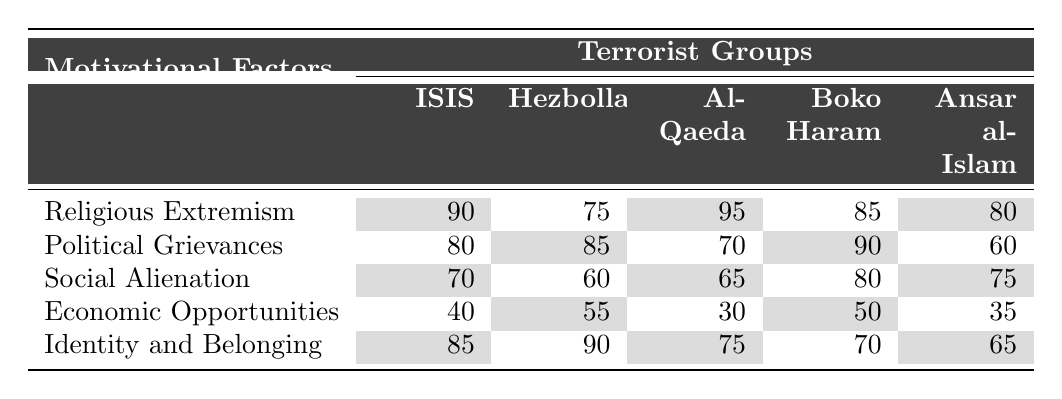What is the highest score for religious extremism among the terrorist groups? The highest score for religious extremism in the table is 95, which is attributed to Al-Qaeda.
Answer: 95 Which terrorist group has the lowest score in economic opportunities? In the table, Al-Qaeda has the lowest score for economic opportunities at 30.
Answer: Al-Qaeda What is the difference in political grievances between Boko Haram and Hezbollah? Boko Haram scores 90, while Hezbollah scores 85. The difference is calculated as 90 - 85 = 5.
Answer: 5 Which terrorist group has the highest score for identity and belonging? The highest score for identity and belonging is 90, seen with Hezbollah.
Answer: Hezbollah Is social alienation a more significant motivational factor for Boko Haram compared to Al-Qaeda? Boko Haram scores 80 for social alienation and Al-Qaeda scores 65. Since 80 > 65, it is true that social alienation is more significant for Boko Haram.
Answer: Yes What is the average score for economic opportunities across all terrorist groups? To calculate the average, sum the scores: 40 + 55 + 30 + 50 + 35 = 210. There are 5 groups, so the average is 210 / 5 = 42.
Answer: 42 Which motivational factor has the lowest overall average score among all groups? The motivational factors are listed with their respective averages: Religious extremism (83), Political grievances (71), Social alienation (64), Economic opportunities (42), Identity and belonging (73). Economic opportunities has the lowest average score at 42.
Answer: Economic opportunities If we consider the scores for political grievances, which group shows the least concern based on its score? Based on the scores: ISIS (80), Hezbollah (85), Al-Qaeda (70), Boko Haram (90), Ansar al-Islam (60), Ansar al-Islam has the lowest score of 60.
Answer: Ansar al-Islam What is the total score for identity and belonging of all the groups combined? The total is calculated as follows: 85 (ISIS) + 90 (Hezbollah) + 75 (Al-Qaeda) + 70 (Boko Haram) + 65 (Ansar al-Islam) = 385.
Answer: 385 Among the groups, which has a better balance between social alienation and economic opportunities? We compare scores: Boko Haram (social alienation 80, economic opportunities 50) has the highest social alienation score along with a mid-range economic opportunities score. ISIS (social alienation 70, economic opportunities 40) ranks lower; hence, Boko Haram maintains a better balance.
Answer: Boko Haram 